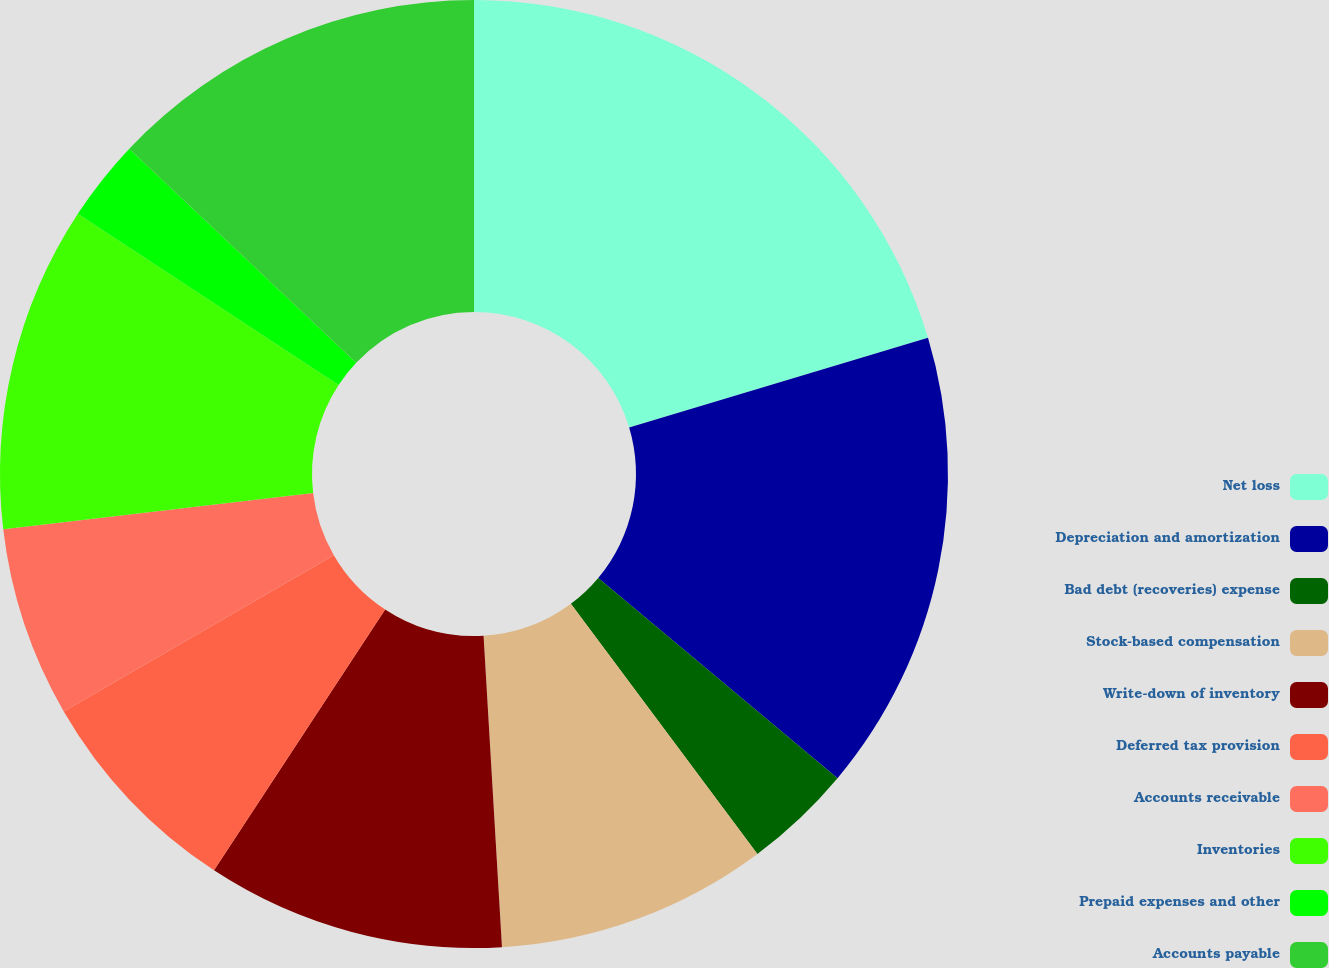<chart> <loc_0><loc_0><loc_500><loc_500><pie_chart><fcel>Net loss<fcel>Depreciation and amortization<fcel>Bad debt (recoveries) expense<fcel>Stock-based compensation<fcel>Write-down of inventory<fcel>Deferred tax provision<fcel>Accounts receivable<fcel>Inventories<fcel>Prepaid expenses and other<fcel>Accounts payable<nl><fcel>20.36%<fcel>15.73%<fcel>3.71%<fcel>9.26%<fcel>10.18%<fcel>7.41%<fcel>6.49%<fcel>11.11%<fcel>2.79%<fcel>12.96%<nl></chart> 